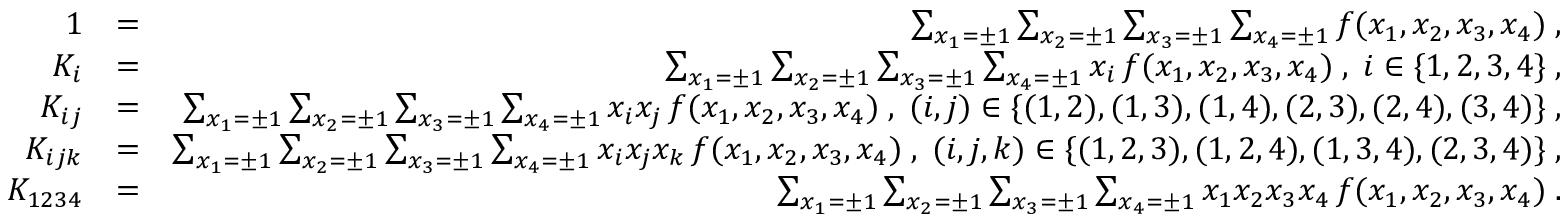Convert formula to latex. <formula><loc_0><loc_0><loc_500><loc_500>\begin{array} { r l r } { 1 } & { = } & { \sum _ { x _ { 1 } = \pm 1 } \sum _ { x _ { 2 } = \pm 1 } \sum _ { x _ { 3 } = \pm 1 } \sum _ { x _ { 4 } = \pm 1 } f ( x _ { 1 } , x _ { 2 } , x _ { 3 } , x _ { 4 } ) \, , } \\ { K _ { i } } & { = } & { \sum _ { x _ { 1 } = \pm 1 } \sum _ { x _ { 2 } = \pm 1 } \sum _ { x _ { 3 } = \pm 1 } \sum _ { x _ { 4 } = \pm 1 } x _ { i } \, f ( x _ { 1 } , x _ { 2 } , x _ { 3 } , x _ { 4 } ) \, , \, i \in \{ 1 , 2 , 3 , 4 \} \, , } \\ { K _ { i j } } & { = } & { \sum _ { x _ { 1 } = \pm 1 } \sum _ { x _ { 2 } = \pm 1 } \sum _ { x _ { 3 } = \pm 1 } \sum _ { x _ { 4 } = \pm 1 } x _ { i } x _ { j } \, f ( x _ { 1 } , x _ { 2 } , x _ { 3 } , x _ { 4 } ) \, , \, ( i , j ) \in \{ ( 1 , 2 ) , ( 1 , 3 ) , ( 1 , 4 ) , ( 2 , 3 ) , ( 2 , 4 ) , ( 3 , 4 ) \} \, , } \\ { K _ { i j k } } & { = } & { \sum _ { x _ { 1 } = \pm 1 } \sum _ { x _ { 2 } = \pm 1 } \sum _ { x _ { 3 } = \pm 1 } \sum _ { x _ { 4 } = \pm 1 } x _ { i } x _ { j } x _ { k } \, f ( x _ { 1 } , x _ { 2 } , x _ { 3 } , x _ { 4 } ) \, , \, ( i , j , k ) \in \{ ( 1 , 2 , 3 ) , ( 1 , 2 , 4 ) , ( 1 , 3 , 4 ) , ( 2 , 3 , 4 ) \} \, , } \\ { K _ { 1 2 3 4 } } & { = } & { \sum _ { x _ { 1 } = \pm 1 } \sum _ { x _ { 2 } = \pm 1 } \sum _ { x _ { 3 } = \pm 1 } \sum _ { x _ { 4 } = \pm 1 } x _ { 1 } x _ { 2 } x _ { 3 } x _ { 4 } \, f ( x _ { 1 } , x _ { 2 } , x _ { 3 } , x _ { 4 } ) \, . } \end{array}</formula> 